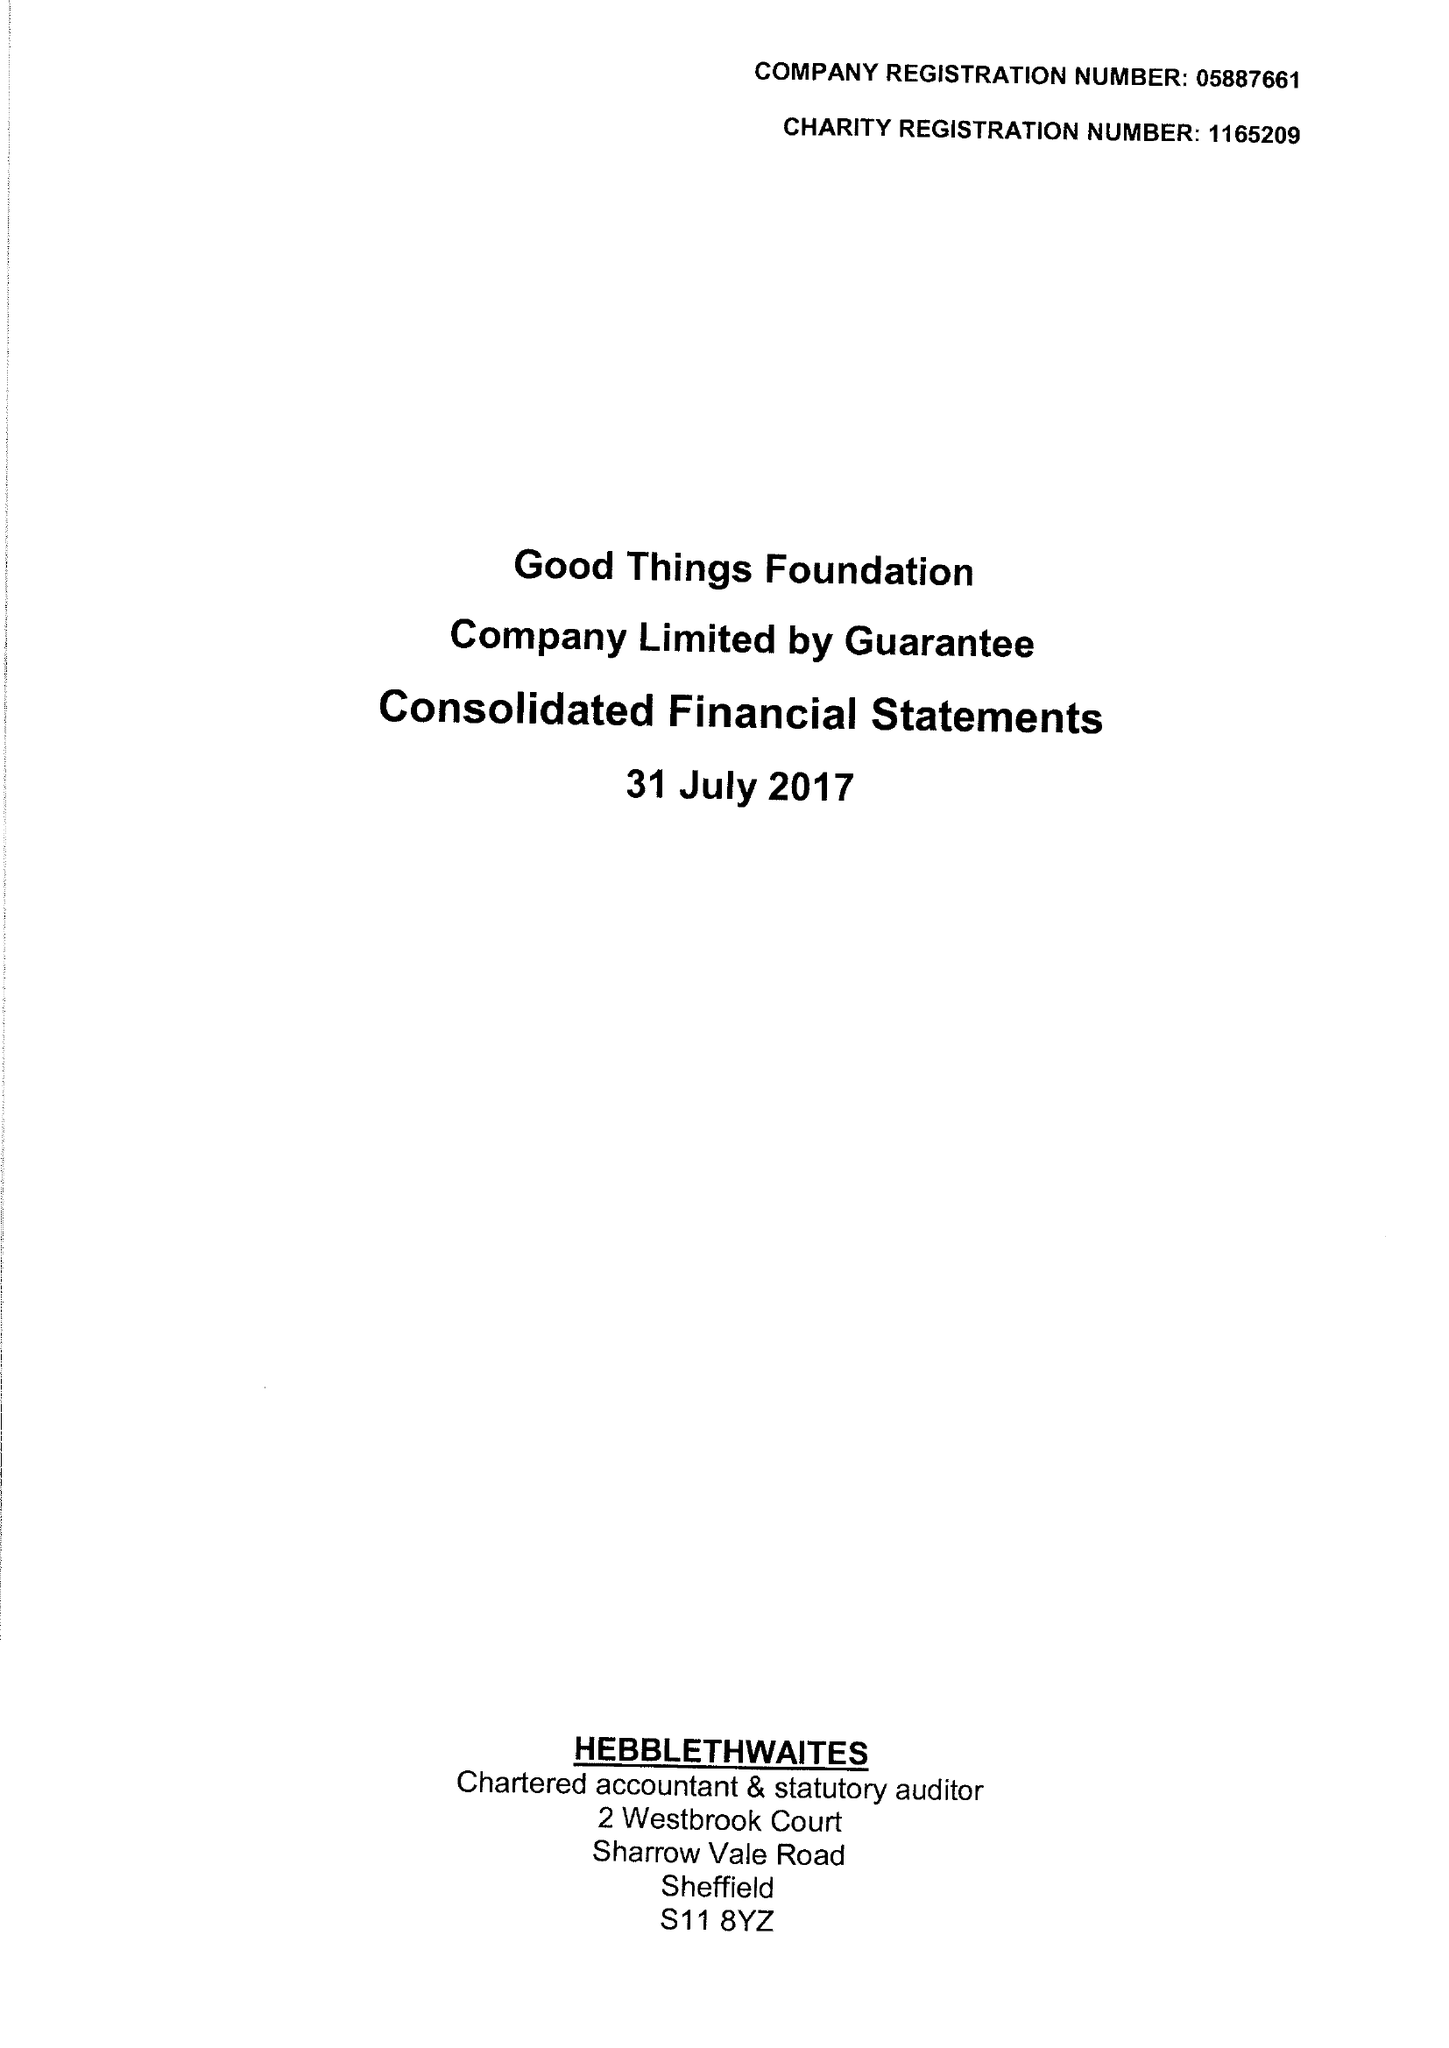What is the value for the charity_number?
Answer the question using a single word or phrase. 1165209 